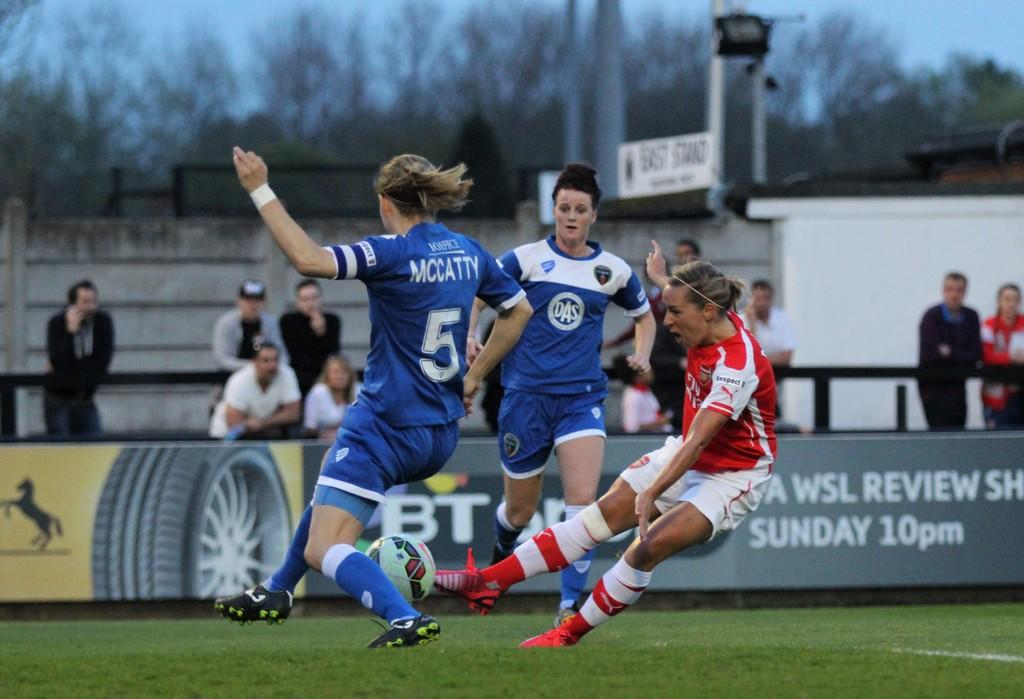<image>
Write a terse but informative summary of the picture. a few soccer players with one girl wearing the number 5 